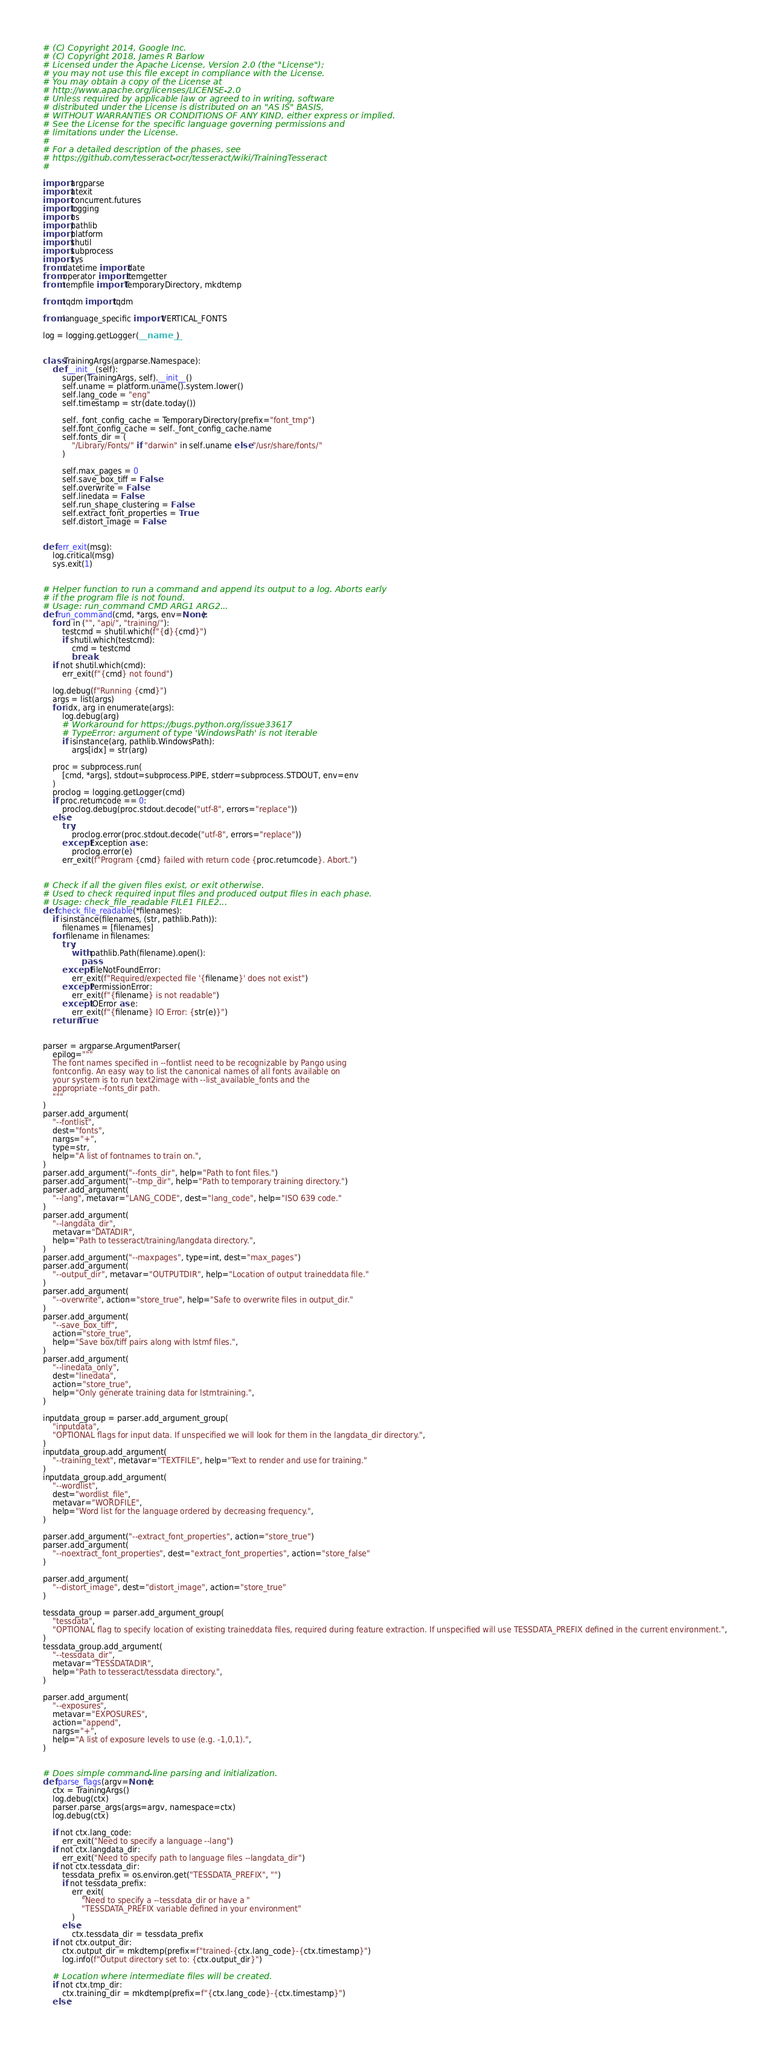Convert code to text. <code><loc_0><loc_0><loc_500><loc_500><_Python_># (C) Copyright 2014, Google Inc.
# (C) Copyright 2018, James R Barlow
# Licensed under the Apache License, Version 2.0 (the "License");
# you may not use this file except in compliance with the License.
# You may obtain a copy of the License at
# http://www.apache.org/licenses/LICENSE-2.0
# Unless required by applicable law or agreed to in writing, software
# distributed under the License is distributed on an "AS IS" BASIS,
# WITHOUT WARRANTIES OR CONDITIONS OF ANY KIND, either express or implied.
# See the License for the specific language governing permissions and
# limitations under the License.
#
# For a detailed description of the phases, see
# https://github.com/tesseract-ocr/tesseract/wiki/TrainingTesseract
#

import argparse
import atexit
import concurrent.futures
import logging
import os
import pathlib
import platform
import shutil
import subprocess
import sys
from datetime import date
from operator import itemgetter
from tempfile import TemporaryDirectory, mkdtemp

from tqdm import tqdm

from language_specific import VERTICAL_FONTS

log = logging.getLogger(__name__)


class TrainingArgs(argparse.Namespace):
    def __init__(self):
        super(TrainingArgs, self).__init__()
        self.uname = platform.uname().system.lower()
        self.lang_code = "eng"
        self.timestamp = str(date.today())

        self._font_config_cache = TemporaryDirectory(prefix="font_tmp")
        self.font_config_cache = self._font_config_cache.name
        self.fonts_dir = (
            "/Library/Fonts/" if "darwin" in self.uname else "/usr/share/fonts/"
        )

        self.max_pages = 0
        self.save_box_tiff = False
        self.overwrite = False
        self.linedata = False
        self.run_shape_clustering = False
        self.extract_font_properties = True
        self.distort_image = False


def err_exit(msg):
    log.critical(msg)
    sys.exit(1)


# Helper function to run a command and append its output to a log. Aborts early
# if the program file is not found.
# Usage: run_command CMD ARG1 ARG2...
def run_command(cmd, *args, env=None):
    for d in ("", "api/", "training/"):
        testcmd = shutil.which(f"{d}{cmd}")
        if shutil.which(testcmd):
            cmd = testcmd
            break
    if not shutil.which(cmd):
        err_exit(f"{cmd} not found")

    log.debug(f"Running {cmd}")
    args = list(args)
    for idx, arg in enumerate(args):
        log.debug(arg)
        # Workaround for https://bugs.python.org/issue33617
        # TypeError: argument of type 'WindowsPath' is not iterable
        if isinstance(arg, pathlib.WindowsPath):
            args[idx] = str(arg)

    proc = subprocess.run(
        [cmd, *args], stdout=subprocess.PIPE, stderr=subprocess.STDOUT, env=env
    )
    proclog = logging.getLogger(cmd)
    if proc.returncode == 0:
        proclog.debug(proc.stdout.decode("utf-8", errors="replace"))
    else:
        try:
            proclog.error(proc.stdout.decode("utf-8", errors="replace"))
        except Exception as e:
            proclog.error(e)
        err_exit(f"Program {cmd} failed with return code {proc.returncode}. Abort.")


# Check if all the given files exist, or exit otherwise.
# Used to check required input files and produced output files in each phase.
# Usage: check_file_readable FILE1 FILE2...
def check_file_readable(*filenames):
    if isinstance(filenames, (str, pathlib.Path)):
        filenames = [filenames]
    for filename in filenames:
        try:
            with pathlib.Path(filename).open():
                pass
        except FileNotFoundError:
            err_exit(f"Required/expected file '{filename}' does not exist")
        except PermissionError:
            err_exit(f"{filename} is not readable")
        except IOError as e:
            err_exit(f"{filename} IO Error: {str(e)}")
    return True


parser = argparse.ArgumentParser(
    epilog="""
    The font names specified in --fontlist need to be recognizable by Pango using
    fontconfig. An easy way to list the canonical names of all fonts available on
    your system is to run text2image with --list_available_fonts and the
    appropriate --fonts_dir path.
    """
)
parser.add_argument(
    "--fontlist",
    dest="fonts",
    nargs="+",
    type=str,
    help="A list of fontnames to train on.",
)
parser.add_argument("--fonts_dir", help="Path to font files.")
parser.add_argument("--tmp_dir", help="Path to temporary training directory.")
parser.add_argument(
    "--lang", metavar="LANG_CODE", dest="lang_code", help="ISO 639 code."
)
parser.add_argument(
    "--langdata_dir",
    metavar="DATADIR",
    help="Path to tesseract/training/langdata directory.",
)
parser.add_argument("--maxpages", type=int, dest="max_pages")
parser.add_argument(
    "--output_dir", metavar="OUTPUTDIR", help="Location of output traineddata file."
)
parser.add_argument(
    "--overwrite", action="store_true", help="Safe to overwrite files in output_dir."
)
parser.add_argument(
    "--save_box_tiff",
    action="store_true",
    help="Save box/tiff pairs along with lstmf files.",
)
parser.add_argument(
    "--linedata_only",
    dest="linedata",
    action="store_true",
    help="Only generate training data for lstmtraining.",
)

inputdata_group = parser.add_argument_group(
    "inputdata",
    "OPTIONAL flags for input data. If unspecified we will look for them in the langdata_dir directory.",
)
inputdata_group.add_argument(
    "--training_text", metavar="TEXTFILE", help="Text to render and use for training."
)
inputdata_group.add_argument(
    "--wordlist",
    dest="wordlist_file",
    metavar="WORDFILE",
    help="Word list for the language ordered by decreasing frequency.",
)

parser.add_argument("--extract_font_properties", action="store_true")
parser.add_argument(
    "--noextract_font_properties", dest="extract_font_properties", action="store_false"
)

parser.add_argument(
    "--distort_image", dest="distort_image", action="store_true"
)

tessdata_group = parser.add_argument_group(
    "tessdata",
    "OPTIONAL flag to specify location of existing traineddata files, required during feature extraction. If unspecified will use TESSDATA_PREFIX defined in the current environment.",
)
tessdata_group.add_argument(
    "--tessdata_dir",
    metavar="TESSDATADIR",
    help="Path to tesseract/tessdata directory.",
)

parser.add_argument(
    "--exposures",
    metavar="EXPOSURES",
    action="append",
    nargs="+",
    help="A list of exposure levels to use (e.g. -1,0,1).",
)


# Does simple command-line parsing and initialization.
def parse_flags(argv=None):
    ctx = TrainingArgs()
    log.debug(ctx)
    parser.parse_args(args=argv, namespace=ctx)
    log.debug(ctx)

    if not ctx.lang_code:
        err_exit("Need to specify a language --lang")
    if not ctx.langdata_dir:
        err_exit("Need to specify path to language files --langdata_dir")
    if not ctx.tessdata_dir:
        tessdata_prefix = os.environ.get("TESSDATA_PREFIX", "")
        if not tessdata_prefix:
            err_exit(
                "Need to specify a --tessdata_dir or have a "
                "TESSDATA_PREFIX variable defined in your environment"
            )
        else:
            ctx.tessdata_dir = tessdata_prefix
    if not ctx.output_dir:
        ctx.output_dir = mkdtemp(prefix=f"trained-{ctx.lang_code}-{ctx.timestamp}")
        log.info(f"Output directory set to: {ctx.output_dir}")

    # Location where intermediate files will be created.
    if not ctx.tmp_dir:
        ctx.training_dir = mkdtemp(prefix=f"{ctx.lang_code}-{ctx.timestamp}")
    else:</code> 